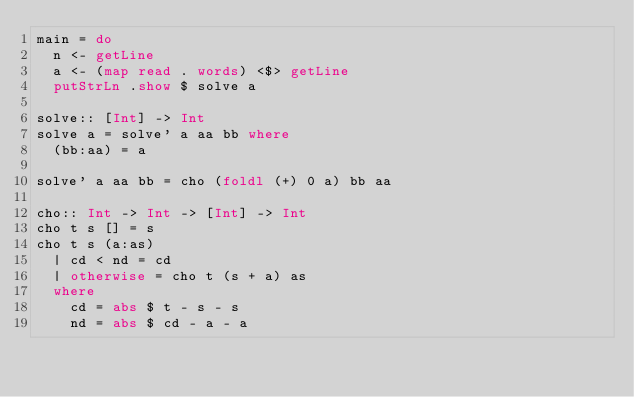Convert code to text. <code><loc_0><loc_0><loc_500><loc_500><_Haskell_>main = do
  n <- getLine
  a <- (map read . words) <$> getLine
  putStrLn .show $ solve a

solve:: [Int] -> Int
solve a = solve' a aa bb where
  (bb:aa) = a

solve' a aa bb = cho (foldl (+) 0 a) bb aa

cho:: Int -> Int -> [Int] -> Int
cho t s [] = s
cho t s (a:as)
  | cd < nd = cd
  | otherwise = cho t (s + a) as
  where
    cd = abs $ t - s - s
    nd = abs $ cd - a - a
</code> 